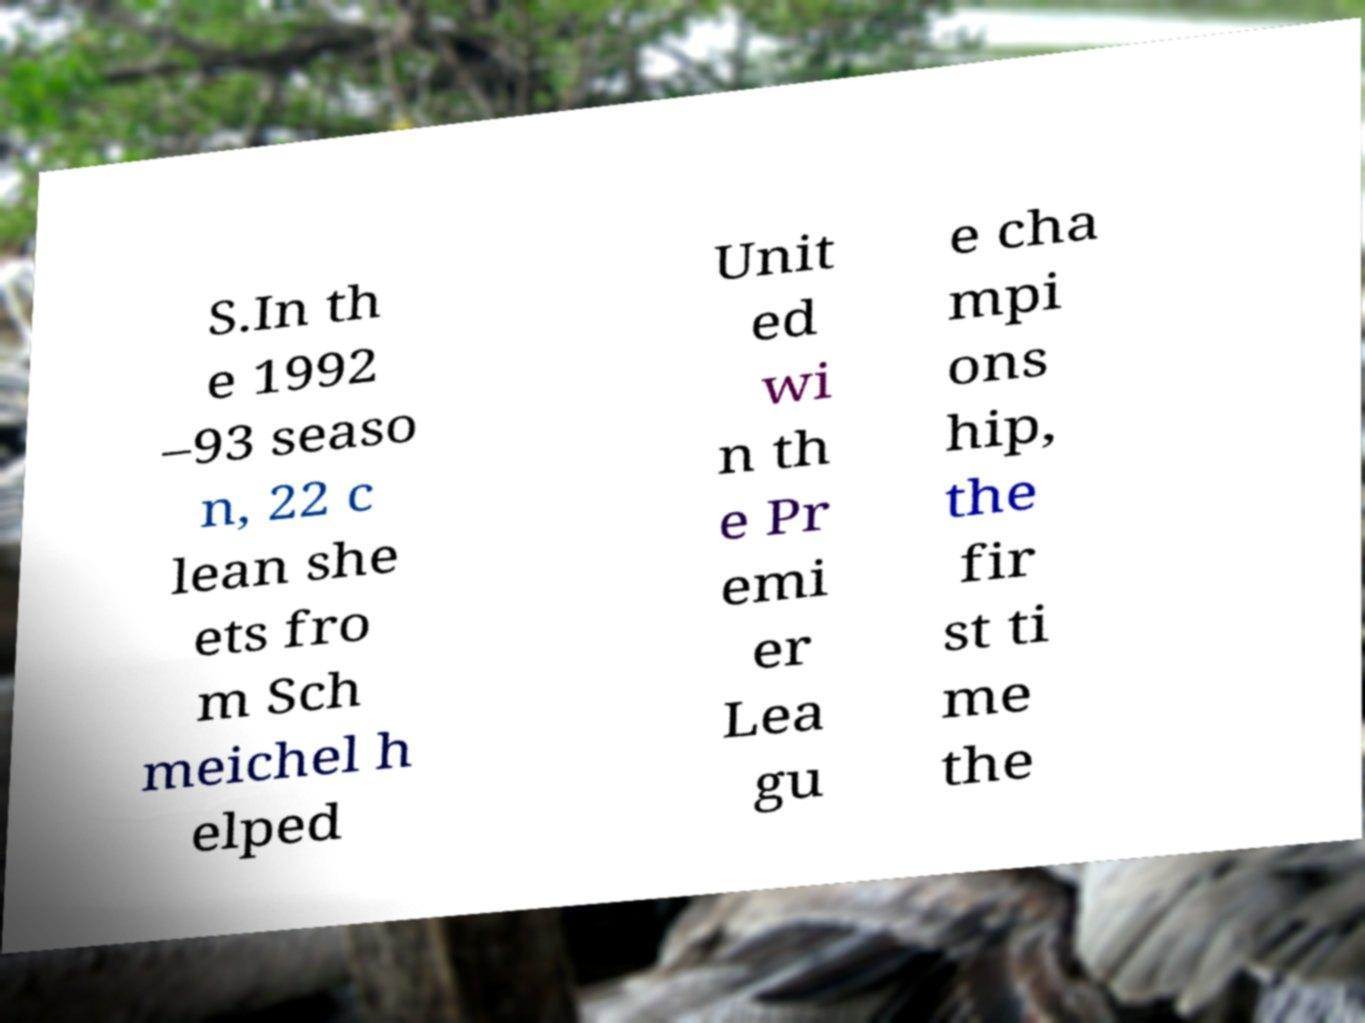There's text embedded in this image that I need extracted. Can you transcribe it verbatim? S.In th e 1992 –93 seaso n, 22 c lean she ets fro m Sch meichel h elped Unit ed wi n th e Pr emi er Lea gu e cha mpi ons hip, the fir st ti me the 